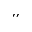Convert formula to latex. <formula><loc_0><loc_0><loc_500><loc_500>^ { \prime \prime }</formula> 